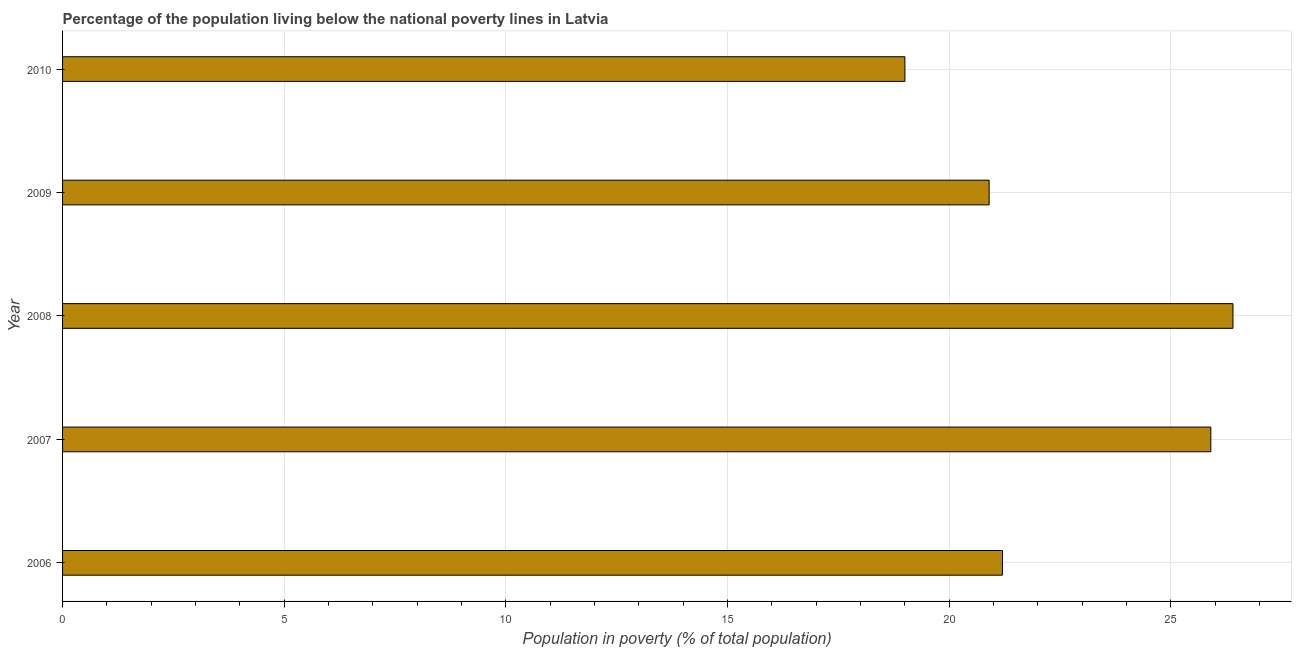Does the graph contain any zero values?
Provide a succinct answer. No. What is the title of the graph?
Provide a short and direct response. Percentage of the population living below the national poverty lines in Latvia. What is the label or title of the X-axis?
Your answer should be very brief. Population in poverty (% of total population). What is the label or title of the Y-axis?
Provide a succinct answer. Year. What is the percentage of population living below poverty line in 2009?
Your response must be concise. 20.9. Across all years, what is the maximum percentage of population living below poverty line?
Provide a succinct answer. 26.4. Across all years, what is the minimum percentage of population living below poverty line?
Offer a very short reply. 19. In which year was the percentage of population living below poverty line minimum?
Your answer should be very brief. 2010. What is the sum of the percentage of population living below poverty line?
Make the answer very short. 113.4. What is the difference between the percentage of population living below poverty line in 2007 and 2009?
Your response must be concise. 5. What is the average percentage of population living below poverty line per year?
Your answer should be compact. 22.68. What is the median percentage of population living below poverty line?
Your answer should be compact. 21.2. In how many years, is the percentage of population living below poverty line greater than 3 %?
Your response must be concise. 5. Do a majority of the years between 2010 and 2007 (inclusive) have percentage of population living below poverty line greater than 21 %?
Your answer should be very brief. Yes. What is the ratio of the percentage of population living below poverty line in 2006 to that in 2007?
Make the answer very short. 0.82. Is the percentage of population living below poverty line in 2007 less than that in 2009?
Your answer should be compact. No. What is the difference between the highest and the second highest percentage of population living below poverty line?
Provide a succinct answer. 0.5. Is the sum of the percentage of population living below poverty line in 2006 and 2010 greater than the maximum percentage of population living below poverty line across all years?
Make the answer very short. Yes. In how many years, is the percentage of population living below poverty line greater than the average percentage of population living below poverty line taken over all years?
Your answer should be compact. 2. How many bars are there?
Your response must be concise. 5. What is the difference between two consecutive major ticks on the X-axis?
Your answer should be very brief. 5. What is the Population in poverty (% of total population) in 2006?
Offer a very short reply. 21.2. What is the Population in poverty (% of total population) in 2007?
Ensure brevity in your answer.  25.9. What is the Population in poverty (% of total population) of 2008?
Offer a very short reply. 26.4. What is the Population in poverty (% of total population) in 2009?
Make the answer very short. 20.9. What is the Population in poverty (% of total population) in 2010?
Offer a terse response. 19. What is the difference between the Population in poverty (% of total population) in 2006 and 2008?
Provide a succinct answer. -5.2. What is the difference between the Population in poverty (% of total population) in 2007 and 2008?
Your response must be concise. -0.5. What is the difference between the Population in poverty (% of total population) in 2007 and 2009?
Your answer should be very brief. 5. What is the difference between the Population in poverty (% of total population) in 2007 and 2010?
Give a very brief answer. 6.9. What is the difference between the Population in poverty (% of total population) in 2008 and 2010?
Provide a succinct answer. 7.4. What is the ratio of the Population in poverty (% of total population) in 2006 to that in 2007?
Provide a short and direct response. 0.82. What is the ratio of the Population in poverty (% of total population) in 2006 to that in 2008?
Provide a succinct answer. 0.8. What is the ratio of the Population in poverty (% of total population) in 2006 to that in 2010?
Your response must be concise. 1.12. What is the ratio of the Population in poverty (% of total population) in 2007 to that in 2008?
Offer a terse response. 0.98. What is the ratio of the Population in poverty (% of total population) in 2007 to that in 2009?
Your response must be concise. 1.24. What is the ratio of the Population in poverty (% of total population) in 2007 to that in 2010?
Your answer should be very brief. 1.36. What is the ratio of the Population in poverty (% of total population) in 2008 to that in 2009?
Provide a succinct answer. 1.26. What is the ratio of the Population in poverty (% of total population) in 2008 to that in 2010?
Your answer should be very brief. 1.39. 